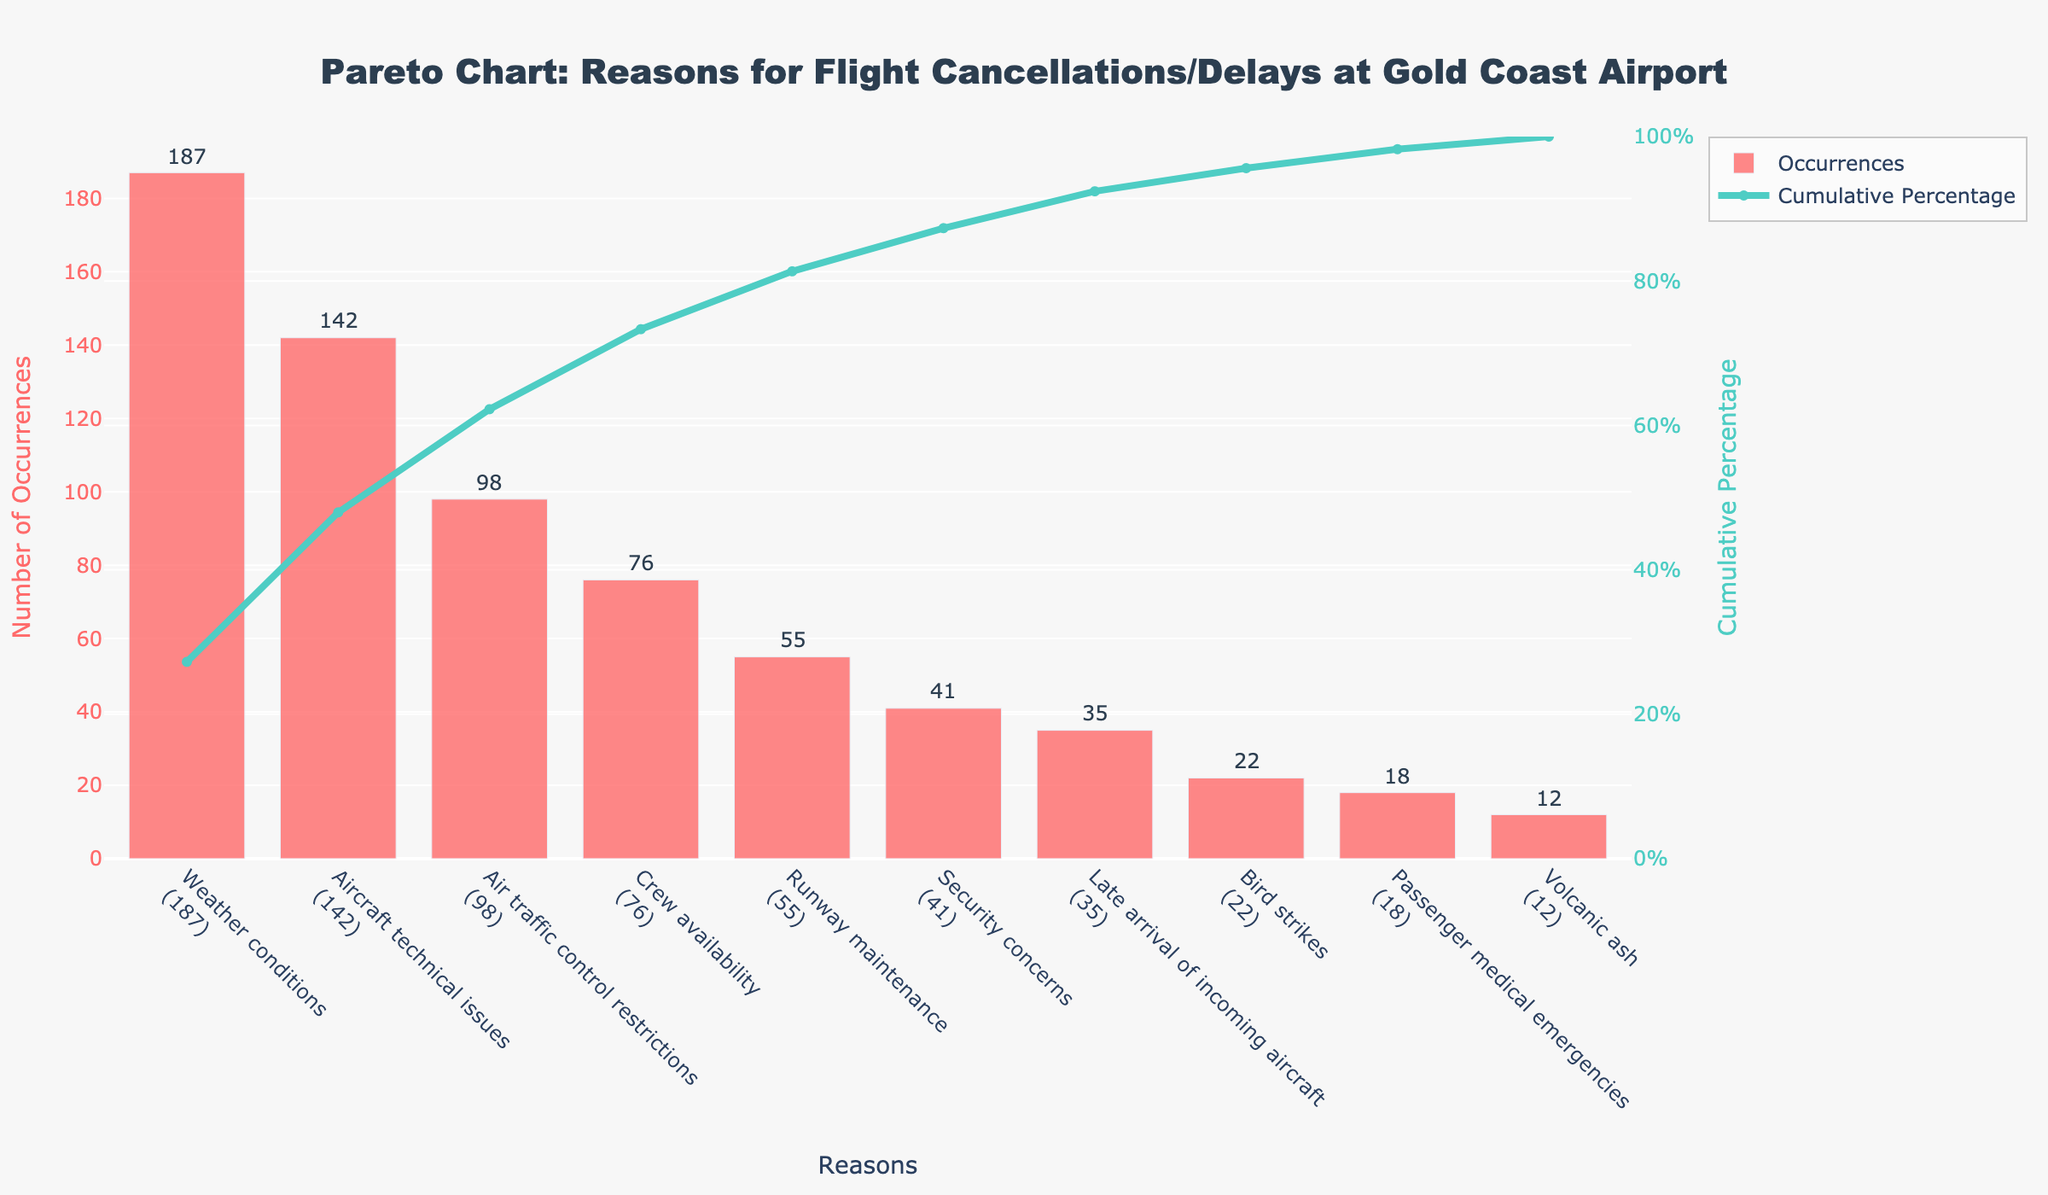What is the most common reason for flight cancellations or delays? The figure's bars show the number of occurrences for each reason. The tallest bar corresponds to "Weather conditions" with 187 occurrences.
Answer: Weather conditions How many occurrences are due to aircraft technical issues? Look at the bar labeled "Aircraft technical issues" and read the value indicated above it, which is 142.
Answer: 142 What is the cumulative percentage that covers both weather conditions and aircraft technical issues? Sum the occurrences for "Weather conditions" and "Aircraft technical issues" (187 + 142 = 329). Then, calculate the percentage over the total occurrences (686). (329 / 686) * 100 ≈ 47.96%.
Answer: 47.96% Which reasons are responsible for less than 50 occurrences? Scan the bars to identify those with occurrences below 50. These are "Security concerns" (41), "Late arrival of incoming aircraft" (35), "Bird strikes" (22), "Passenger medical emergencies" (18), and "Volcanic ash" (12).
Answer: Security concerns, Late arrival of incoming aircraft, Bird strikes, Passenger medical emergencies, Volcanic ash By approximately what cumulative percentage do the top three reasons (Weather conditions, Aircraft technical issues, and Air traffic control restrictions) account for the occurrences? Sum the occurrences for the top three reasons (187 + 142 + 98 = 427), then divide by the total and multiply by 100. (427 / 686) * 100 ≈ 62.25%.
Answer: 62.25% What range does the cumulative percentage cover over the x-axis? The cumulative percentage line starts at 0% and reaches 100% by the last data point.
Answer: 0% to 100% Compare the number of occurrences due to crew availability and runway maintenance. Which one is higher? Identify the bars for "Crew availability" (76 occurrences) and "Runway maintenance" (55 occurrences). 76 is higher than 55.
Answer: Crew availability How much does the least frequent reason for cancellations or delays contribute to the cumulative percentage? The least frequent reason is "Volcanic ash" with 12 occurrences. The cumulative percentage for this is roughly at the end of the line which is close to 100%. Specifically, the cumulative percentage when adding 12 is (674 + 12) / 686 * 100 ≈ 98.25%.
Answer: 98.25% What cumulative percentage do bird strikes and passenger medical emergencies together contribute to? Sum the occurrences of "Bird strikes" (22) and "Passenger medical emergencies" (18) to get 40. Then divide by the total and multiply by 100. (40 / 686) * 100 ≈ 5.83%.
Answer: 5.83% Which reason has the closest number of occurrences to 100? Look for the reason nearest to 100 occurrences. "Air traffic control restrictions" has 98 occurrences, which is closest to 100.
Answer: Air traffic control restrictions 